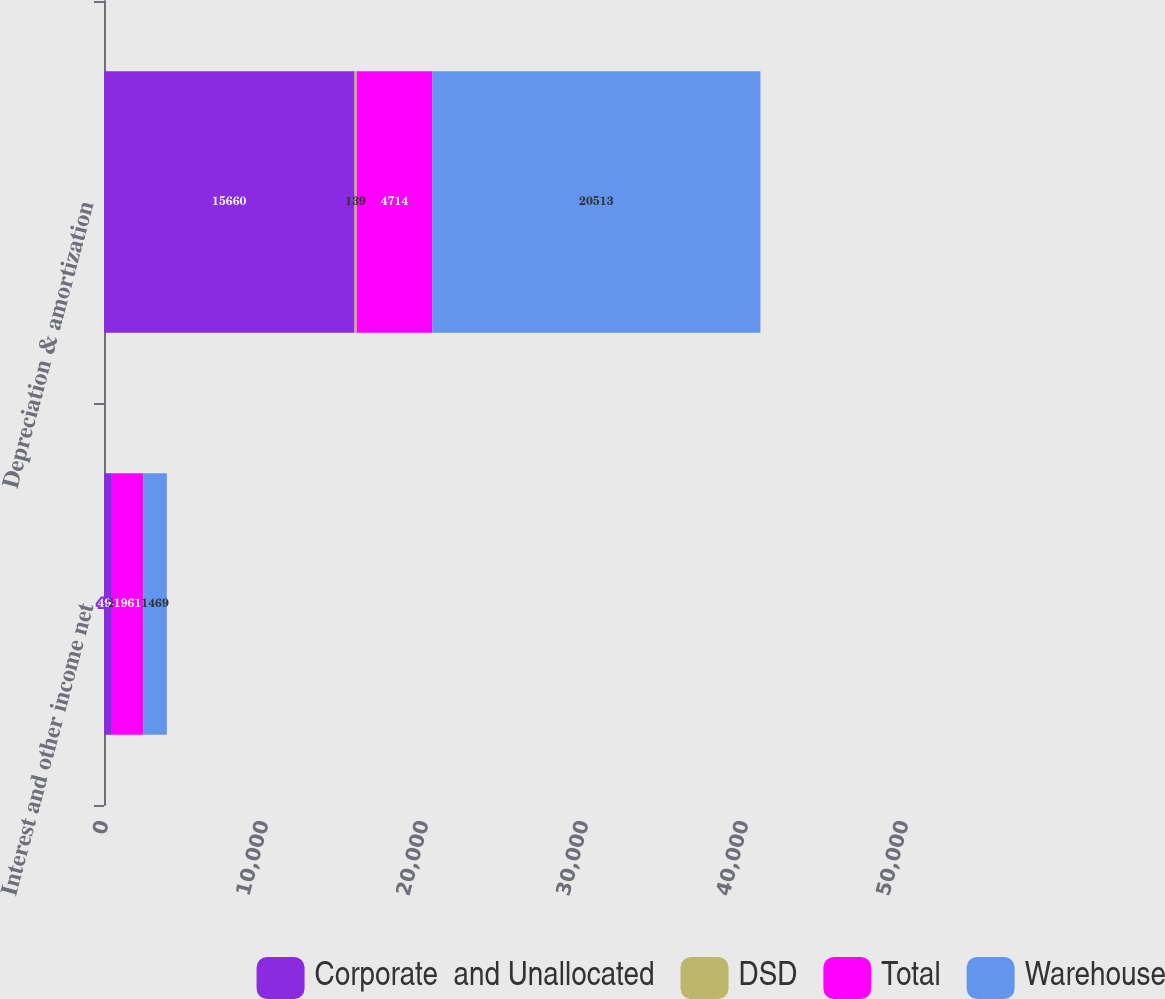Convert chart. <chart><loc_0><loc_0><loc_500><loc_500><stacked_bar_chart><ecel><fcel>Interest and other income net<fcel>Depreciation & amortization<nl><fcel>Corporate  and Unallocated<fcel>494<fcel>15660<nl><fcel>DSD<fcel>2<fcel>139<nl><fcel>Total<fcel>1961<fcel>4714<nl><fcel>Warehouse<fcel>1469<fcel>20513<nl></chart> 